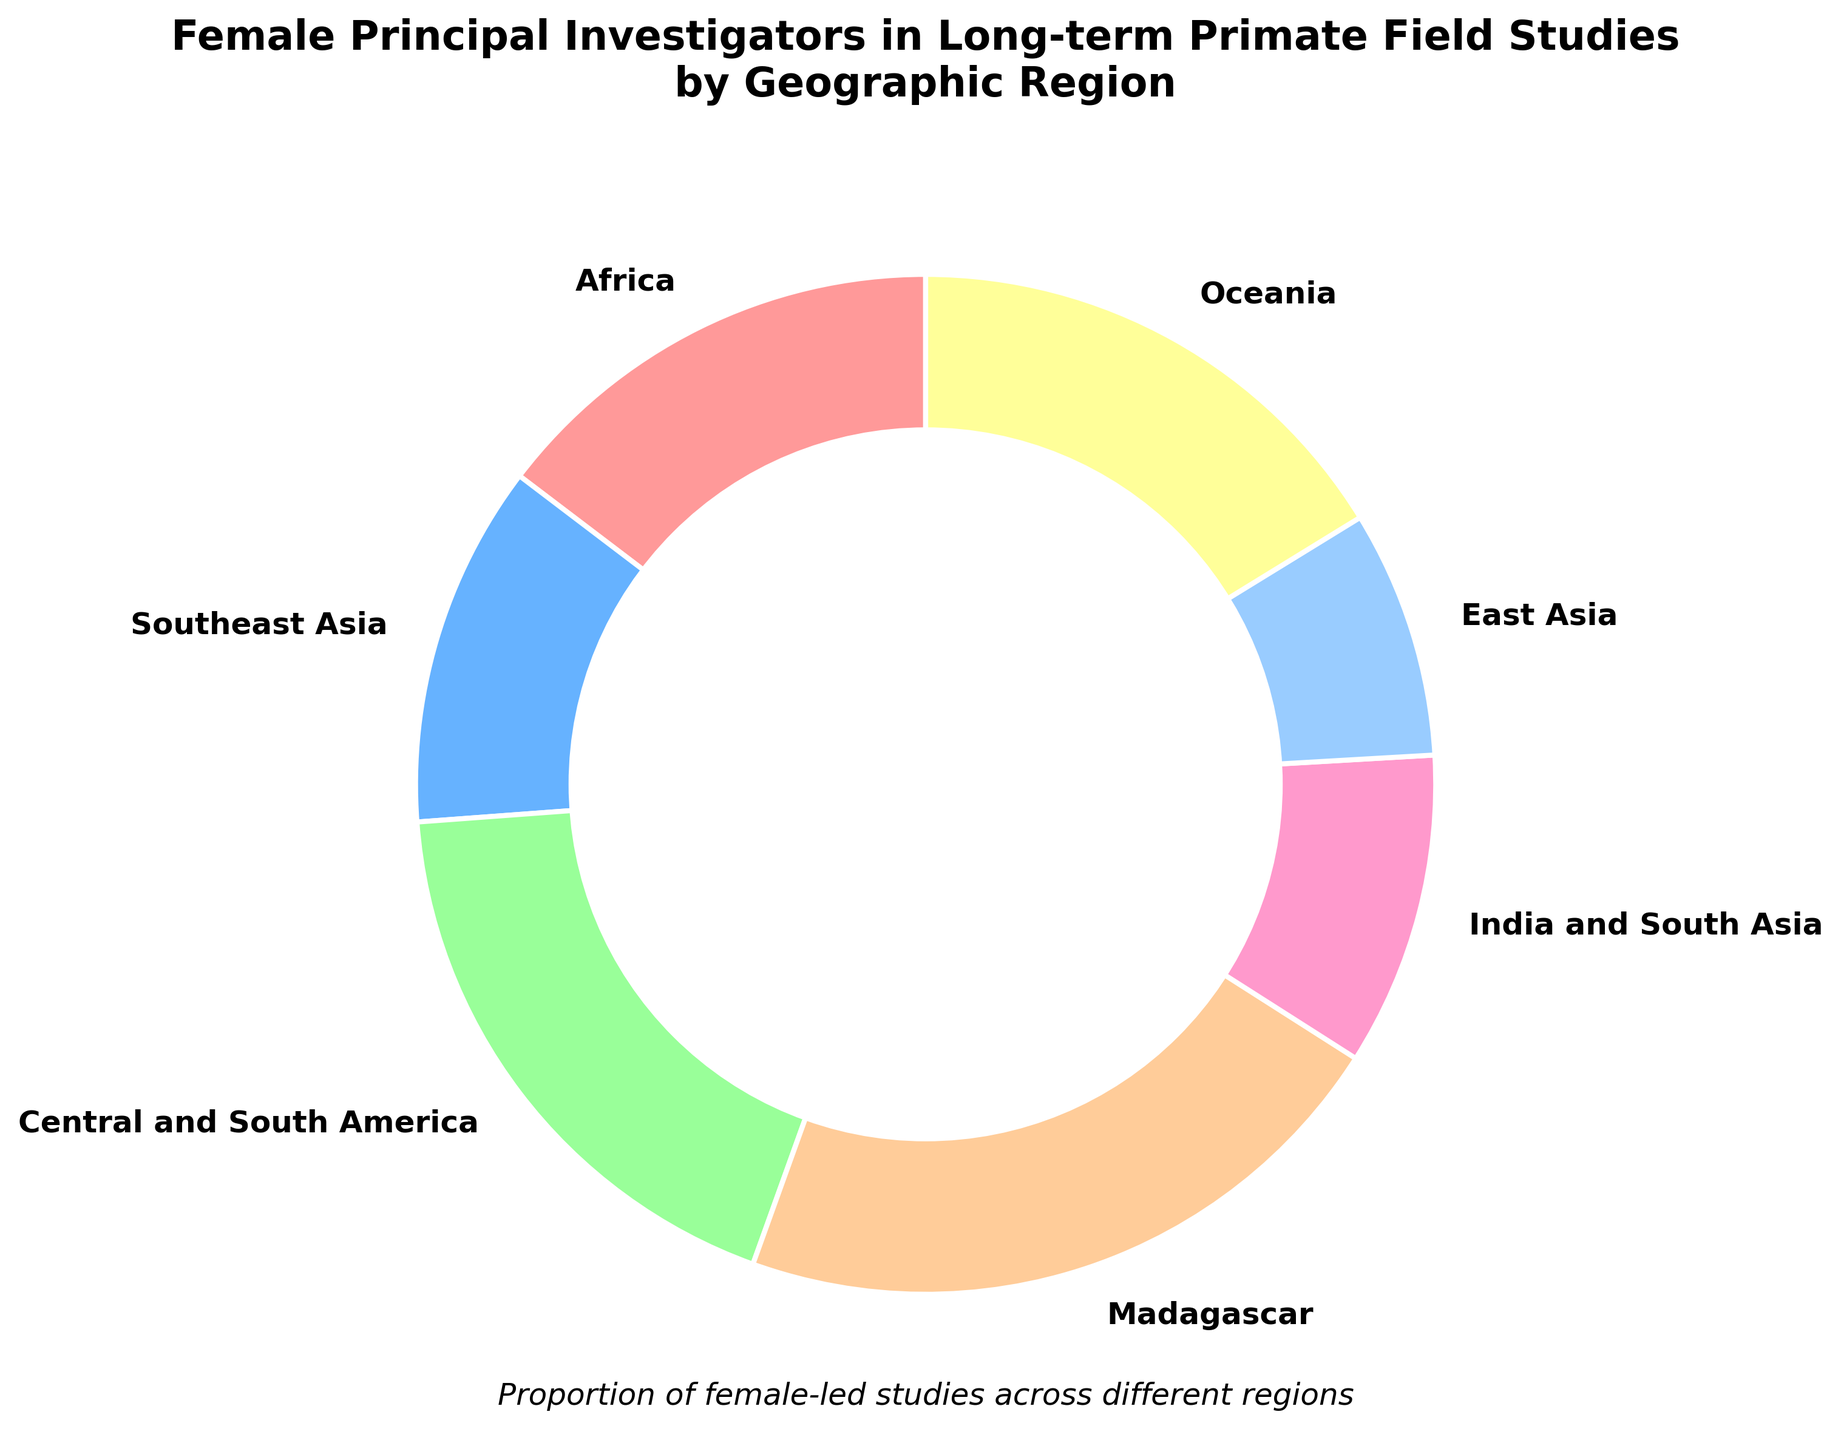What is the region with the highest proportion of female principal investigators leading long-term primate field studies? Look at the pie chart and identify the segment with the highest percentage label. In this case, Madagascar has the highest proportion at 41%.
Answer: Madagascar Which region has the lowest proportion of female principal investigators leading long-term primate field studies? Look at the pie chart and identify the segment with the lowest percentage label. East Asia has the lowest proportion at 15%.
Answer: East Asia How does the proportion of female principal investigators in Africa compare to that in Southeast Asia? Compare the percentages for Africa and Southeast Asia in the pie chart. Africa has 28%, while Southeast Asia has 22%, so Africa has a higher proportion.
Answer: Africa What is the total proportion of female principal investigators for Central and South America, and Oceania combined? Identify the percentages for Central and South America (35%) and Oceania (31%), then add them together: 35% + 31% = 66%.
Answer: 66% Which regions have a proportion of female principal investigators greater than 30%? Look at the pie chart and identify regions with percentages greater than 30%. These regions are Central and South America (35%), Madagascar (41%), and Oceania (31%).
Answer: Central and South America, Madagascar, Oceania What is the difference in the proportion of female principal investigators between the regions with the highest and lowest percentages? Find the regions with the highest (Madagascar, 41%) and lowest (East Asia, 15%) proportions, then calculate the difference: 41% - 15% = 26%.
Answer: 26% What is the average proportion of female principal investigators across all the regions? Sum the percentages of all regions (28 + 22 + 35 + 41 + 19 + 15 + 31 = 191) and divide by the number of regions (7): 191 / 7 ≈ 27.3%.
Answer: 27.3% How many regions have a percentage close (within 10%) to the global average? Calculate the global average (27.3%), then check each region to see if their percentages fall within the range of 17.3% to 37.3%. The regions are Africa (28%), Southeast Asia (22%), Central and South America (35%), India and South Asia (19%), and Oceania (31%).
Answer: 5 